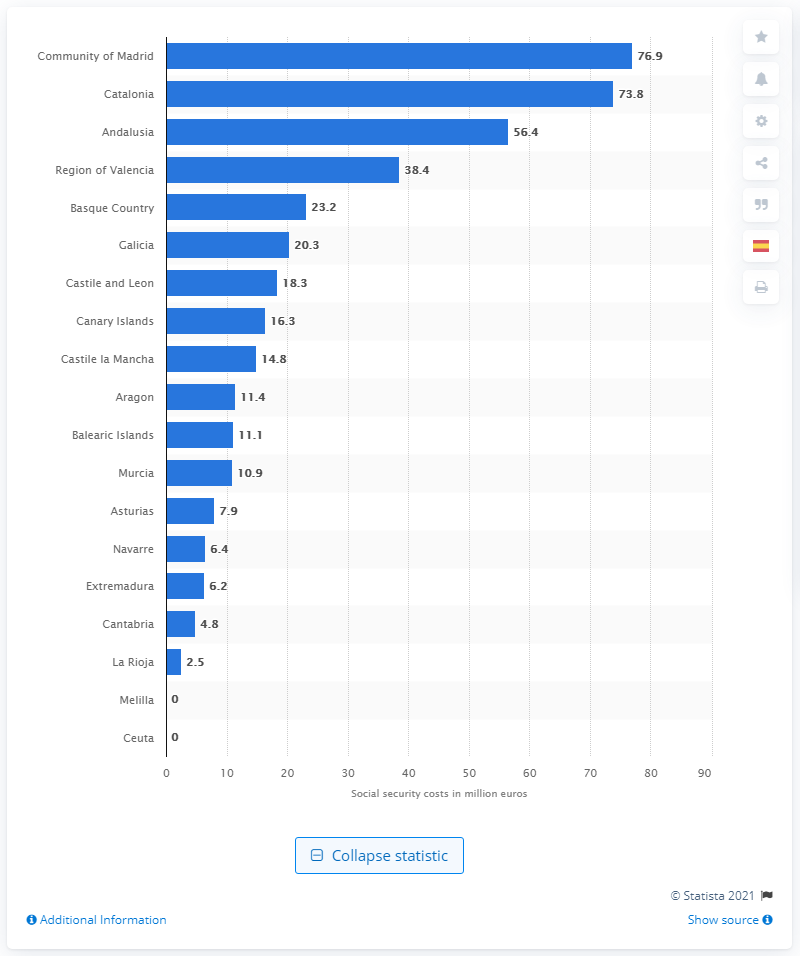Outline some significant characteristics in this image. The estimated cost of social security in Madrid is 76.9%. 